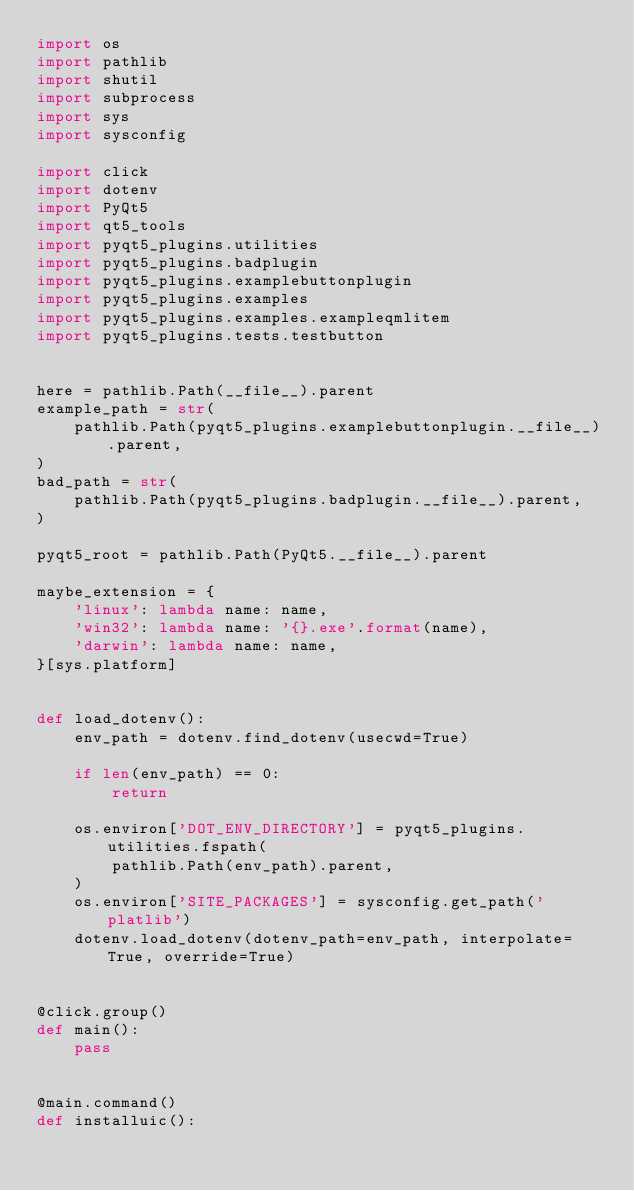<code> <loc_0><loc_0><loc_500><loc_500><_Python_>import os
import pathlib
import shutil
import subprocess
import sys
import sysconfig

import click
import dotenv
import PyQt5
import qt5_tools
import pyqt5_plugins.utilities
import pyqt5_plugins.badplugin
import pyqt5_plugins.examplebuttonplugin
import pyqt5_plugins.examples
import pyqt5_plugins.examples.exampleqmlitem
import pyqt5_plugins.tests.testbutton


here = pathlib.Path(__file__).parent
example_path = str(
    pathlib.Path(pyqt5_plugins.examplebuttonplugin.__file__).parent,
)
bad_path = str(
    pathlib.Path(pyqt5_plugins.badplugin.__file__).parent,
)

pyqt5_root = pathlib.Path(PyQt5.__file__).parent

maybe_extension = {
    'linux': lambda name: name,
    'win32': lambda name: '{}.exe'.format(name),
    'darwin': lambda name: name,
}[sys.platform]


def load_dotenv():
    env_path = dotenv.find_dotenv(usecwd=True)

    if len(env_path) == 0:
        return

    os.environ['DOT_ENV_DIRECTORY'] = pyqt5_plugins.utilities.fspath(
        pathlib.Path(env_path).parent,
    )
    os.environ['SITE_PACKAGES'] = sysconfig.get_path('platlib')
    dotenv.load_dotenv(dotenv_path=env_path, interpolate=True, override=True)


@click.group()
def main():
    pass


@main.command()
def installuic():</code> 